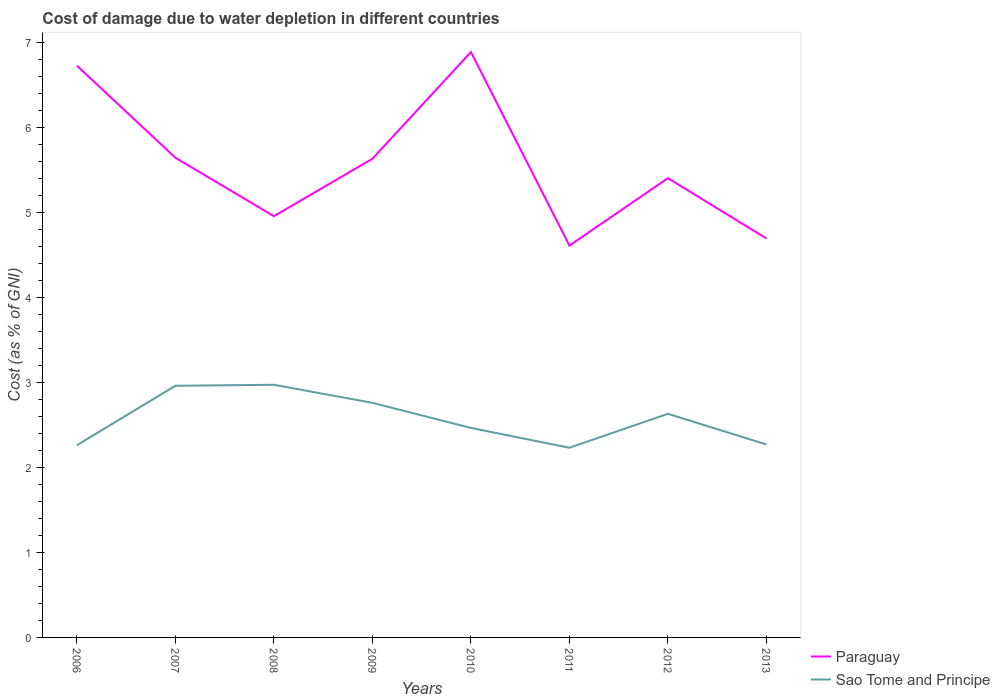How many different coloured lines are there?
Your answer should be very brief. 2. Is the number of lines equal to the number of legend labels?
Make the answer very short. Yes. Across all years, what is the maximum cost of damage caused due to water depletion in Paraguay?
Your answer should be compact. 4.61. What is the total cost of damage caused due to water depletion in Sao Tome and Principe in the graph?
Give a very brief answer. -0.4. What is the difference between the highest and the second highest cost of damage caused due to water depletion in Paraguay?
Your answer should be very brief. 2.28. Is the cost of damage caused due to water depletion in Sao Tome and Principe strictly greater than the cost of damage caused due to water depletion in Paraguay over the years?
Ensure brevity in your answer.  Yes. How many years are there in the graph?
Offer a terse response. 8. What is the difference between two consecutive major ticks on the Y-axis?
Provide a succinct answer. 1. Are the values on the major ticks of Y-axis written in scientific E-notation?
Your response must be concise. No. What is the title of the graph?
Ensure brevity in your answer.  Cost of damage due to water depletion in different countries. What is the label or title of the X-axis?
Offer a very short reply. Years. What is the label or title of the Y-axis?
Your response must be concise. Cost (as % of GNI). What is the Cost (as % of GNI) of Paraguay in 2006?
Offer a very short reply. 6.72. What is the Cost (as % of GNI) of Sao Tome and Principe in 2006?
Your answer should be compact. 2.26. What is the Cost (as % of GNI) in Paraguay in 2007?
Your response must be concise. 5.64. What is the Cost (as % of GNI) in Sao Tome and Principe in 2007?
Make the answer very short. 2.96. What is the Cost (as % of GNI) of Paraguay in 2008?
Offer a very short reply. 4.95. What is the Cost (as % of GNI) of Sao Tome and Principe in 2008?
Your answer should be compact. 2.97. What is the Cost (as % of GNI) in Paraguay in 2009?
Give a very brief answer. 5.63. What is the Cost (as % of GNI) in Sao Tome and Principe in 2009?
Make the answer very short. 2.76. What is the Cost (as % of GNI) in Paraguay in 2010?
Offer a terse response. 6.88. What is the Cost (as % of GNI) of Sao Tome and Principe in 2010?
Ensure brevity in your answer.  2.46. What is the Cost (as % of GNI) in Paraguay in 2011?
Keep it short and to the point. 4.61. What is the Cost (as % of GNI) in Sao Tome and Principe in 2011?
Your answer should be very brief. 2.23. What is the Cost (as % of GNI) in Paraguay in 2012?
Give a very brief answer. 5.4. What is the Cost (as % of GNI) in Sao Tome and Principe in 2012?
Your answer should be very brief. 2.63. What is the Cost (as % of GNI) in Paraguay in 2013?
Your answer should be compact. 4.69. What is the Cost (as % of GNI) of Sao Tome and Principe in 2013?
Your response must be concise. 2.27. Across all years, what is the maximum Cost (as % of GNI) of Paraguay?
Offer a very short reply. 6.88. Across all years, what is the maximum Cost (as % of GNI) of Sao Tome and Principe?
Ensure brevity in your answer.  2.97. Across all years, what is the minimum Cost (as % of GNI) of Paraguay?
Offer a terse response. 4.61. Across all years, what is the minimum Cost (as % of GNI) in Sao Tome and Principe?
Offer a terse response. 2.23. What is the total Cost (as % of GNI) of Paraguay in the graph?
Your answer should be compact. 44.53. What is the total Cost (as % of GNI) in Sao Tome and Principe in the graph?
Your answer should be compact. 20.54. What is the difference between the Cost (as % of GNI) in Paraguay in 2006 and that in 2007?
Provide a short and direct response. 1.08. What is the difference between the Cost (as % of GNI) of Sao Tome and Principe in 2006 and that in 2007?
Your answer should be compact. -0.7. What is the difference between the Cost (as % of GNI) of Paraguay in 2006 and that in 2008?
Offer a terse response. 1.77. What is the difference between the Cost (as % of GNI) in Sao Tome and Principe in 2006 and that in 2008?
Your response must be concise. -0.71. What is the difference between the Cost (as % of GNI) of Paraguay in 2006 and that in 2009?
Your response must be concise. 1.09. What is the difference between the Cost (as % of GNI) of Sao Tome and Principe in 2006 and that in 2009?
Your answer should be compact. -0.5. What is the difference between the Cost (as % of GNI) of Paraguay in 2006 and that in 2010?
Ensure brevity in your answer.  -0.16. What is the difference between the Cost (as % of GNI) in Sao Tome and Principe in 2006 and that in 2010?
Offer a terse response. -0.2. What is the difference between the Cost (as % of GNI) in Paraguay in 2006 and that in 2011?
Ensure brevity in your answer.  2.12. What is the difference between the Cost (as % of GNI) in Sao Tome and Principe in 2006 and that in 2011?
Provide a short and direct response. 0.03. What is the difference between the Cost (as % of GNI) of Paraguay in 2006 and that in 2012?
Make the answer very short. 1.32. What is the difference between the Cost (as % of GNI) in Sao Tome and Principe in 2006 and that in 2012?
Provide a short and direct response. -0.37. What is the difference between the Cost (as % of GNI) in Paraguay in 2006 and that in 2013?
Your response must be concise. 2.03. What is the difference between the Cost (as % of GNI) of Sao Tome and Principe in 2006 and that in 2013?
Provide a succinct answer. -0.01. What is the difference between the Cost (as % of GNI) of Paraguay in 2007 and that in 2008?
Offer a very short reply. 0.69. What is the difference between the Cost (as % of GNI) of Sao Tome and Principe in 2007 and that in 2008?
Provide a succinct answer. -0.01. What is the difference between the Cost (as % of GNI) in Paraguay in 2007 and that in 2009?
Your answer should be compact. 0.01. What is the difference between the Cost (as % of GNI) of Sao Tome and Principe in 2007 and that in 2009?
Your response must be concise. 0.2. What is the difference between the Cost (as % of GNI) in Paraguay in 2007 and that in 2010?
Offer a very short reply. -1.24. What is the difference between the Cost (as % of GNI) in Sao Tome and Principe in 2007 and that in 2010?
Provide a succinct answer. 0.5. What is the difference between the Cost (as % of GNI) of Paraguay in 2007 and that in 2011?
Offer a very short reply. 1.03. What is the difference between the Cost (as % of GNI) of Sao Tome and Principe in 2007 and that in 2011?
Give a very brief answer. 0.73. What is the difference between the Cost (as % of GNI) of Paraguay in 2007 and that in 2012?
Offer a terse response. 0.24. What is the difference between the Cost (as % of GNI) of Sao Tome and Principe in 2007 and that in 2012?
Your answer should be very brief. 0.33. What is the difference between the Cost (as % of GNI) of Paraguay in 2007 and that in 2013?
Ensure brevity in your answer.  0.95. What is the difference between the Cost (as % of GNI) of Sao Tome and Principe in 2007 and that in 2013?
Your answer should be very brief. 0.69. What is the difference between the Cost (as % of GNI) in Paraguay in 2008 and that in 2009?
Offer a terse response. -0.68. What is the difference between the Cost (as % of GNI) of Sao Tome and Principe in 2008 and that in 2009?
Keep it short and to the point. 0.21. What is the difference between the Cost (as % of GNI) in Paraguay in 2008 and that in 2010?
Make the answer very short. -1.93. What is the difference between the Cost (as % of GNI) of Sao Tome and Principe in 2008 and that in 2010?
Offer a terse response. 0.51. What is the difference between the Cost (as % of GNI) in Paraguay in 2008 and that in 2011?
Offer a very short reply. 0.35. What is the difference between the Cost (as % of GNI) in Sao Tome and Principe in 2008 and that in 2011?
Provide a short and direct response. 0.74. What is the difference between the Cost (as % of GNI) of Paraguay in 2008 and that in 2012?
Give a very brief answer. -0.45. What is the difference between the Cost (as % of GNI) in Sao Tome and Principe in 2008 and that in 2012?
Your answer should be compact. 0.34. What is the difference between the Cost (as % of GNI) of Paraguay in 2008 and that in 2013?
Make the answer very short. 0.26. What is the difference between the Cost (as % of GNI) in Sao Tome and Principe in 2008 and that in 2013?
Your answer should be compact. 0.7. What is the difference between the Cost (as % of GNI) in Paraguay in 2009 and that in 2010?
Offer a very short reply. -1.26. What is the difference between the Cost (as % of GNI) in Sao Tome and Principe in 2009 and that in 2010?
Your answer should be compact. 0.3. What is the difference between the Cost (as % of GNI) of Paraguay in 2009 and that in 2011?
Provide a short and direct response. 1.02. What is the difference between the Cost (as % of GNI) of Sao Tome and Principe in 2009 and that in 2011?
Give a very brief answer. 0.53. What is the difference between the Cost (as % of GNI) of Paraguay in 2009 and that in 2012?
Give a very brief answer. 0.23. What is the difference between the Cost (as % of GNI) in Sao Tome and Principe in 2009 and that in 2012?
Ensure brevity in your answer.  0.13. What is the difference between the Cost (as % of GNI) in Paraguay in 2009 and that in 2013?
Keep it short and to the point. 0.94. What is the difference between the Cost (as % of GNI) of Sao Tome and Principe in 2009 and that in 2013?
Your answer should be very brief. 0.49. What is the difference between the Cost (as % of GNI) of Paraguay in 2010 and that in 2011?
Your answer should be compact. 2.28. What is the difference between the Cost (as % of GNI) in Sao Tome and Principe in 2010 and that in 2011?
Ensure brevity in your answer.  0.23. What is the difference between the Cost (as % of GNI) of Paraguay in 2010 and that in 2012?
Your answer should be very brief. 1.48. What is the difference between the Cost (as % of GNI) of Sao Tome and Principe in 2010 and that in 2012?
Your response must be concise. -0.17. What is the difference between the Cost (as % of GNI) of Paraguay in 2010 and that in 2013?
Offer a very short reply. 2.19. What is the difference between the Cost (as % of GNI) in Sao Tome and Principe in 2010 and that in 2013?
Your answer should be very brief. 0.19. What is the difference between the Cost (as % of GNI) of Paraguay in 2011 and that in 2012?
Make the answer very short. -0.79. What is the difference between the Cost (as % of GNI) in Sao Tome and Principe in 2011 and that in 2012?
Make the answer very short. -0.4. What is the difference between the Cost (as % of GNI) of Paraguay in 2011 and that in 2013?
Offer a very short reply. -0.08. What is the difference between the Cost (as % of GNI) in Sao Tome and Principe in 2011 and that in 2013?
Ensure brevity in your answer.  -0.04. What is the difference between the Cost (as % of GNI) in Paraguay in 2012 and that in 2013?
Your answer should be compact. 0.71. What is the difference between the Cost (as % of GNI) in Sao Tome and Principe in 2012 and that in 2013?
Your response must be concise. 0.36. What is the difference between the Cost (as % of GNI) in Paraguay in 2006 and the Cost (as % of GNI) in Sao Tome and Principe in 2007?
Provide a succinct answer. 3.76. What is the difference between the Cost (as % of GNI) in Paraguay in 2006 and the Cost (as % of GNI) in Sao Tome and Principe in 2008?
Your response must be concise. 3.75. What is the difference between the Cost (as % of GNI) of Paraguay in 2006 and the Cost (as % of GNI) of Sao Tome and Principe in 2009?
Your response must be concise. 3.96. What is the difference between the Cost (as % of GNI) in Paraguay in 2006 and the Cost (as % of GNI) in Sao Tome and Principe in 2010?
Provide a succinct answer. 4.26. What is the difference between the Cost (as % of GNI) of Paraguay in 2006 and the Cost (as % of GNI) of Sao Tome and Principe in 2011?
Offer a terse response. 4.49. What is the difference between the Cost (as % of GNI) of Paraguay in 2006 and the Cost (as % of GNI) of Sao Tome and Principe in 2012?
Your response must be concise. 4.09. What is the difference between the Cost (as % of GNI) in Paraguay in 2006 and the Cost (as % of GNI) in Sao Tome and Principe in 2013?
Offer a terse response. 4.45. What is the difference between the Cost (as % of GNI) in Paraguay in 2007 and the Cost (as % of GNI) in Sao Tome and Principe in 2008?
Ensure brevity in your answer.  2.67. What is the difference between the Cost (as % of GNI) of Paraguay in 2007 and the Cost (as % of GNI) of Sao Tome and Principe in 2009?
Make the answer very short. 2.88. What is the difference between the Cost (as % of GNI) of Paraguay in 2007 and the Cost (as % of GNI) of Sao Tome and Principe in 2010?
Give a very brief answer. 3.18. What is the difference between the Cost (as % of GNI) of Paraguay in 2007 and the Cost (as % of GNI) of Sao Tome and Principe in 2011?
Your answer should be very brief. 3.41. What is the difference between the Cost (as % of GNI) in Paraguay in 2007 and the Cost (as % of GNI) in Sao Tome and Principe in 2012?
Your response must be concise. 3.01. What is the difference between the Cost (as % of GNI) in Paraguay in 2007 and the Cost (as % of GNI) in Sao Tome and Principe in 2013?
Make the answer very short. 3.37. What is the difference between the Cost (as % of GNI) of Paraguay in 2008 and the Cost (as % of GNI) of Sao Tome and Principe in 2009?
Your answer should be compact. 2.19. What is the difference between the Cost (as % of GNI) in Paraguay in 2008 and the Cost (as % of GNI) in Sao Tome and Principe in 2010?
Your answer should be very brief. 2.49. What is the difference between the Cost (as % of GNI) of Paraguay in 2008 and the Cost (as % of GNI) of Sao Tome and Principe in 2011?
Your answer should be compact. 2.72. What is the difference between the Cost (as % of GNI) in Paraguay in 2008 and the Cost (as % of GNI) in Sao Tome and Principe in 2012?
Ensure brevity in your answer.  2.32. What is the difference between the Cost (as % of GNI) in Paraguay in 2008 and the Cost (as % of GNI) in Sao Tome and Principe in 2013?
Make the answer very short. 2.68. What is the difference between the Cost (as % of GNI) of Paraguay in 2009 and the Cost (as % of GNI) of Sao Tome and Principe in 2010?
Make the answer very short. 3.17. What is the difference between the Cost (as % of GNI) in Paraguay in 2009 and the Cost (as % of GNI) in Sao Tome and Principe in 2011?
Ensure brevity in your answer.  3.4. What is the difference between the Cost (as % of GNI) of Paraguay in 2009 and the Cost (as % of GNI) of Sao Tome and Principe in 2012?
Offer a terse response. 3. What is the difference between the Cost (as % of GNI) in Paraguay in 2009 and the Cost (as % of GNI) in Sao Tome and Principe in 2013?
Your answer should be very brief. 3.36. What is the difference between the Cost (as % of GNI) of Paraguay in 2010 and the Cost (as % of GNI) of Sao Tome and Principe in 2011?
Offer a terse response. 4.65. What is the difference between the Cost (as % of GNI) in Paraguay in 2010 and the Cost (as % of GNI) in Sao Tome and Principe in 2012?
Give a very brief answer. 4.25. What is the difference between the Cost (as % of GNI) in Paraguay in 2010 and the Cost (as % of GNI) in Sao Tome and Principe in 2013?
Offer a terse response. 4.62. What is the difference between the Cost (as % of GNI) in Paraguay in 2011 and the Cost (as % of GNI) in Sao Tome and Principe in 2012?
Your response must be concise. 1.98. What is the difference between the Cost (as % of GNI) of Paraguay in 2011 and the Cost (as % of GNI) of Sao Tome and Principe in 2013?
Your answer should be very brief. 2.34. What is the difference between the Cost (as % of GNI) of Paraguay in 2012 and the Cost (as % of GNI) of Sao Tome and Principe in 2013?
Make the answer very short. 3.13. What is the average Cost (as % of GNI) of Paraguay per year?
Your answer should be compact. 5.57. What is the average Cost (as % of GNI) of Sao Tome and Principe per year?
Provide a short and direct response. 2.57. In the year 2006, what is the difference between the Cost (as % of GNI) of Paraguay and Cost (as % of GNI) of Sao Tome and Principe?
Give a very brief answer. 4.46. In the year 2007, what is the difference between the Cost (as % of GNI) of Paraguay and Cost (as % of GNI) of Sao Tome and Principe?
Provide a short and direct response. 2.68. In the year 2008, what is the difference between the Cost (as % of GNI) of Paraguay and Cost (as % of GNI) of Sao Tome and Principe?
Ensure brevity in your answer.  1.98. In the year 2009, what is the difference between the Cost (as % of GNI) of Paraguay and Cost (as % of GNI) of Sao Tome and Principe?
Offer a terse response. 2.87. In the year 2010, what is the difference between the Cost (as % of GNI) of Paraguay and Cost (as % of GNI) of Sao Tome and Principe?
Your response must be concise. 4.42. In the year 2011, what is the difference between the Cost (as % of GNI) of Paraguay and Cost (as % of GNI) of Sao Tome and Principe?
Give a very brief answer. 2.38. In the year 2012, what is the difference between the Cost (as % of GNI) of Paraguay and Cost (as % of GNI) of Sao Tome and Principe?
Your response must be concise. 2.77. In the year 2013, what is the difference between the Cost (as % of GNI) in Paraguay and Cost (as % of GNI) in Sao Tome and Principe?
Ensure brevity in your answer.  2.42. What is the ratio of the Cost (as % of GNI) in Paraguay in 2006 to that in 2007?
Your response must be concise. 1.19. What is the ratio of the Cost (as % of GNI) of Sao Tome and Principe in 2006 to that in 2007?
Provide a succinct answer. 0.76. What is the ratio of the Cost (as % of GNI) of Paraguay in 2006 to that in 2008?
Provide a short and direct response. 1.36. What is the ratio of the Cost (as % of GNI) in Sao Tome and Principe in 2006 to that in 2008?
Make the answer very short. 0.76. What is the ratio of the Cost (as % of GNI) of Paraguay in 2006 to that in 2009?
Give a very brief answer. 1.19. What is the ratio of the Cost (as % of GNI) in Sao Tome and Principe in 2006 to that in 2009?
Make the answer very short. 0.82. What is the ratio of the Cost (as % of GNI) of Paraguay in 2006 to that in 2010?
Provide a succinct answer. 0.98. What is the ratio of the Cost (as % of GNI) of Sao Tome and Principe in 2006 to that in 2010?
Make the answer very short. 0.92. What is the ratio of the Cost (as % of GNI) of Paraguay in 2006 to that in 2011?
Provide a succinct answer. 1.46. What is the ratio of the Cost (as % of GNI) of Sao Tome and Principe in 2006 to that in 2011?
Your response must be concise. 1.01. What is the ratio of the Cost (as % of GNI) in Paraguay in 2006 to that in 2012?
Your answer should be compact. 1.24. What is the ratio of the Cost (as % of GNI) in Sao Tome and Principe in 2006 to that in 2012?
Provide a short and direct response. 0.86. What is the ratio of the Cost (as % of GNI) in Paraguay in 2006 to that in 2013?
Provide a succinct answer. 1.43. What is the ratio of the Cost (as % of GNI) in Paraguay in 2007 to that in 2008?
Offer a terse response. 1.14. What is the ratio of the Cost (as % of GNI) in Sao Tome and Principe in 2007 to that in 2008?
Offer a terse response. 1. What is the ratio of the Cost (as % of GNI) of Sao Tome and Principe in 2007 to that in 2009?
Give a very brief answer. 1.07. What is the ratio of the Cost (as % of GNI) of Paraguay in 2007 to that in 2010?
Keep it short and to the point. 0.82. What is the ratio of the Cost (as % of GNI) in Sao Tome and Principe in 2007 to that in 2010?
Provide a short and direct response. 1.2. What is the ratio of the Cost (as % of GNI) in Paraguay in 2007 to that in 2011?
Your answer should be very brief. 1.22. What is the ratio of the Cost (as % of GNI) in Sao Tome and Principe in 2007 to that in 2011?
Your answer should be compact. 1.33. What is the ratio of the Cost (as % of GNI) in Paraguay in 2007 to that in 2012?
Offer a very short reply. 1.04. What is the ratio of the Cost (as % of GNI) in Sao Tome and Principe in 2007 to that in 2012?
Offer a terse response. 1.13. What is the ratio of the Cost (as % of GNI) in Paraguay in 2007 to that in 2013?
Your response must be concise. 1.2. What is the ratio of the Cost (as % of GNI) in Sao Tome and Principe in 2007 to that in 2013?
Keep it short and to the point. 1.3. What is the ratio of the Cost (as % of GNI) of Paraguay in 2008 to that in 2009?
Offer a very short reply. 0.88. What is the ratio of the Cost (as % of GNI) of Sao Tome and Principe in 2008 to that in 2009?
Make the answer very short. 1.08. What is the ratio of the Cost (as % of GNI) of Paraguay in 2008 to that in 2010?
Provide a succinct answer. 0.72. What is the ratio of the Cost (as % of GNI) of Sao Tome and Principe in 2008 to that in 2010?
Offer a terse response. 1.21. What is the ratio of the Cost (as % of GNI) in Paraguay in 2008 to that in 2011?
Provide a succinct answer. 1.07. What is the ratio of the Cost (as % of GNI) of Sao Tome and Principe in 2008 to that in 2011?
Offer a terse response. 1.33. What is the ratio of the Cost (as % of GNI) of Paraguay in 2008 to that in 2012?
Make the answer very short. 0.92. What is the ratio of the Cost (as % of GNI) of Sao Tome and Principe in 2008 to that in 2012?
Provide a short and direct response. 1.13. What is the ratio of the Cost (as % of GNI) of Paraguay in 2008 to that in 2013?
Offer a very short reply. 1.06. What is the ratio of the Cost (as % of GNI) in Sao Tome and Principe in 2008 to that in 2013?
Ensure brevity in your answer.  1.31. What is the ratio of the Cost (as % of GNI) in Paraguay in 2009 to that in 2010?
Your answer should be very brief. 0.82. What is the ratio of the Cost (as % of GNI) of Sao Tome and Principe in 2009 to that in 2010?
Your response must be concise. 1.12. What is the ratio of the Cost (as % of GNI) of Paraguay in 2009 to that in 2011?
Offer a very short reply. 1.22. What is the ratio of the Cost (as % of GNI) in Sao Tome and Principe in 2009 to that in 2011?
Offer a terse response. 1.24. What is the ratio of the Cost (as % of GNI) of Paraguay in 2009 to that in 2012?
Ensure brevity in your answer.  1.04. What is the ratio of the Cost (as % of GNI) in Sao Tome and Principe in 2009 to that in 2012?
Provide a short and direct response. 1.05. What is the ratio of the Cost (as % of GNI) in Paraguay in 2009 to that in 2013?
Your response must be concise. 1.2. What is the ratio of the Cost (as % of GNI) of Sao Tome and Principe in 2009 to that in 2013?
Keep it short and to the point. 1.22. What is the ratio of the Cost (as % of GNI) in Paraguay in 2010 to that in 2011?
Offer a terse response. 1.49. What is the ratio of the Cost (as % of GNI) of Sao Tome and Principe in 2010 to that in 2011?
Offer a very short reply. 1.1. What is the ratio of the Cost (as % of GNI) of Paraguay in 2010 to that in 2012?
Keep it short and to the point. 1.27. What is the ratio of the Cost (as % of GNI) of Sao Tome and Principe in 2010 to that in 2012?
Provide a succinct answer. 0.94. What is the ratio of the Cost (as % of GNI) in Paraguay in 2010 to that in 2013?
Make the answer very short. 1.47. What is the ratio of the Cost (as % of GNI) in Sao Tome and Principe in 2010 to that in 2013?
Provide a short and direct response. 1.09. What is the ratio of the Cost (as % of GNI) in Paraguay in 2011 to that in 2012?
Keep it short and to the point. 0.85. What is the ratio of the Cost (as % of GNI) in Sao Tome and Principe in 2011 to that in 2012?
Keep it short and to the point. 0.85. What is the ratio of the Cost (as % of GNI) in Paraguay in 2011 to that in 2013?
Make the answer very short. 0.98. What is the ratio of the Cost (as % of GNI) of Sao Tome and Principe in 2011 to that in 2013?
Provide a short and direct response. 0.98. What is the ratio of the Cost (as % of GNI) of Paraguay in 2012 to that in 2013?
Your response must be concise. 1.15. What is the ratio of the Cost (as % of GNI) of Sao Tome and Principe in 2012 to that in 2013?
Your answer should be compact. 1.16. What is the difference between the highest and the second highest Cost (as % of GNI) of Paraguay?
Give a very brief answer. 0.16. What is the difference between the highest and the second highest Cost (as % of GNI) in Sao Tome and Principe?
Ensure brevity in your answer.  0.01. What is the difference between the highest and the lowest Cost (as % of GNI) in Paraguay?
Your answer should be very brief. 2.28. What is the difference between the highest and the lowest Cost (as % of GNI) of Sao Tome and Principe?
Your answer should be compact. 0.74. 